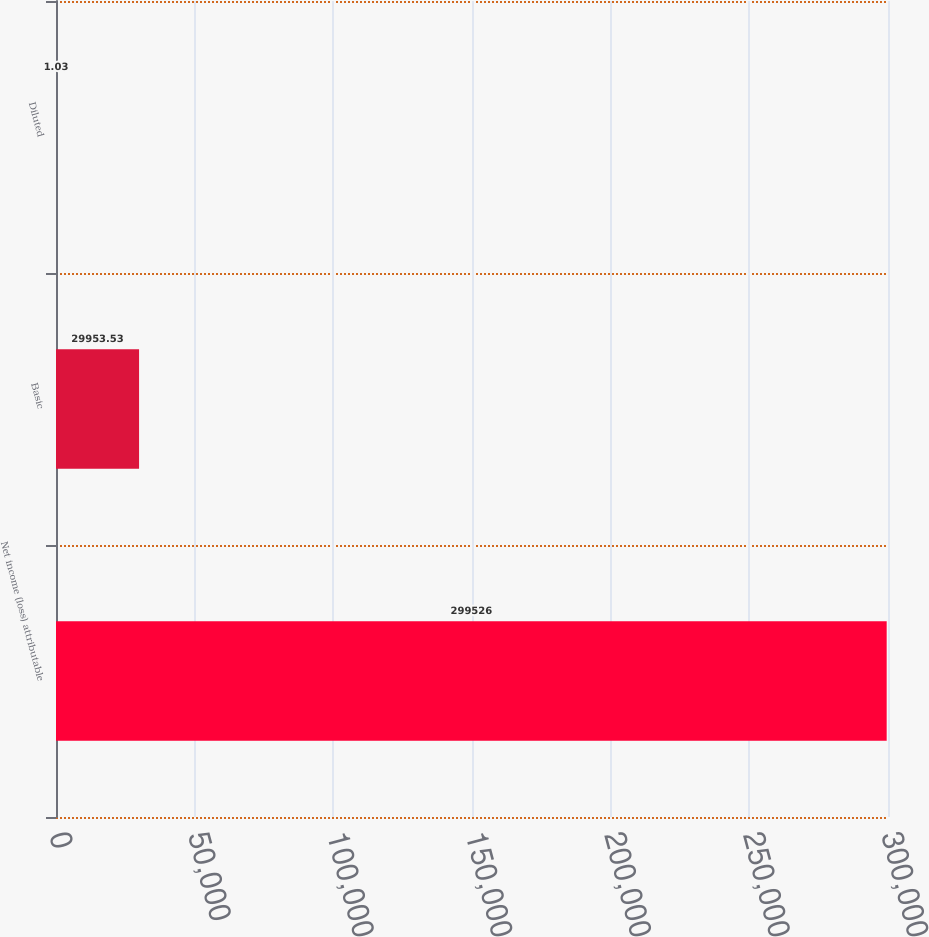Convert chart. <chart><loc_0><loc_0><loc_500><loc_500><bar_chart><fcel>Net income (loss) attributable<fcel>Basic<fcel>Diluted<nl><fcel>299526<fcel>29953.5<fcel>1.03<nl></chart> 